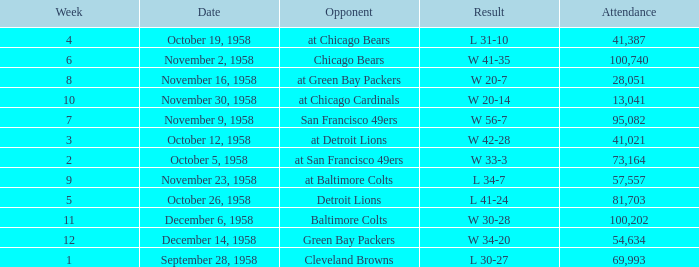What was the higest attendance on November 9, 1958? 95082.0. 